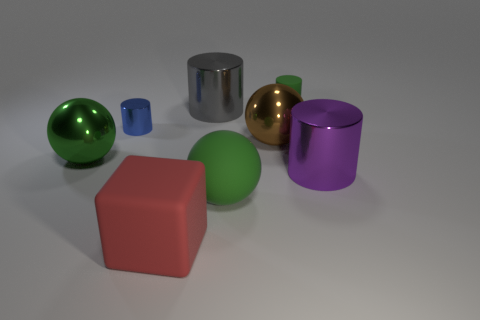Subtract all cyan cylinders. Subtract all brown blocks. How many cylinders are left? 4 Add 1 tiny metal objects. How many objects exist? 9 Subtract all spheres. How many objects are left? 5 Subtract 0 red spheres. How many objects are left? 8 Subtract all large green matte spheres. Subtract all purple cylinders. How many objects are left? 6 Add 2 large brown spheres. How many large brown spheres are left? 3 Add 5 big gray rubber blocks. How many big gray rubber blocks exist? 5 